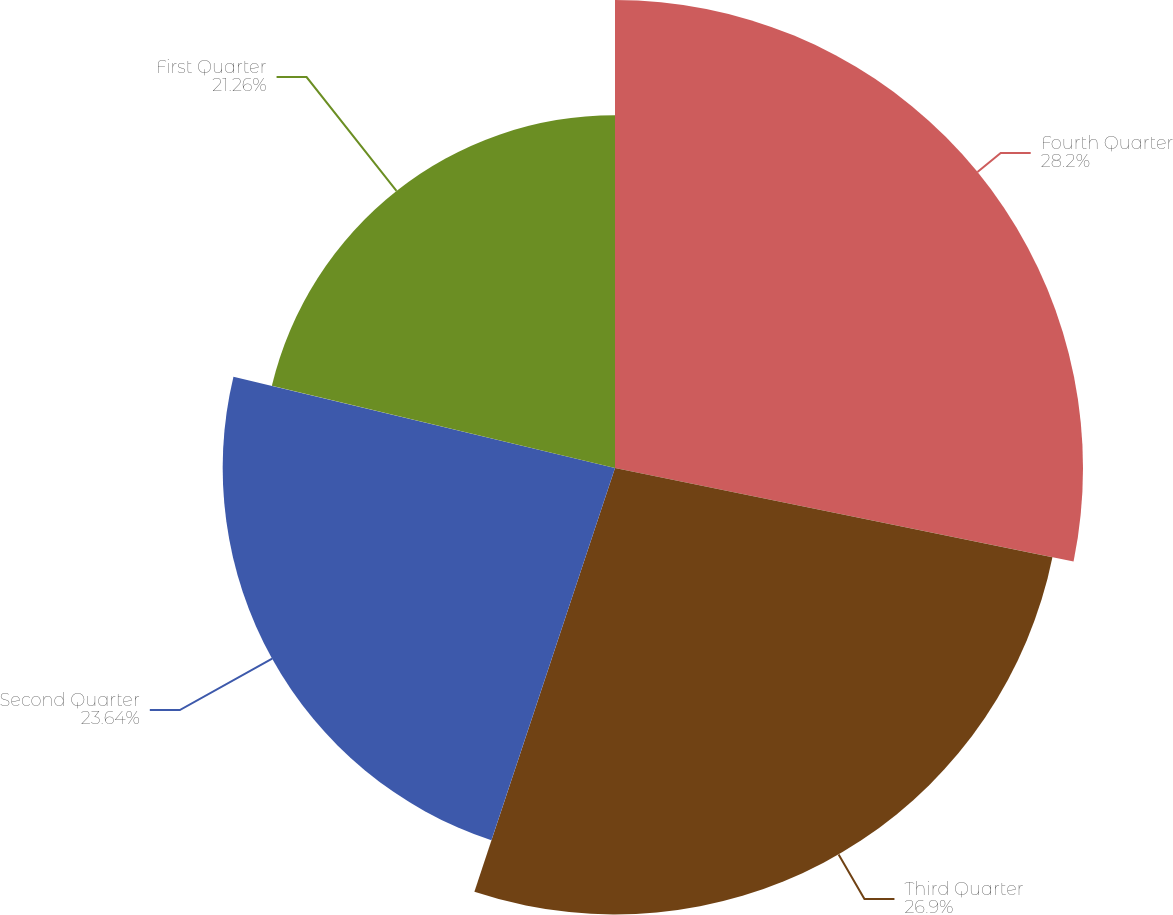<chart> <loc_0><loc_0><loc_500><loc_500><pie_chart><fcel>Fourth Quarter<fcel>Third Quarter<fcel>Second Quarter<fcel>First Quarter<nl><fcel>28.2%<fcel>26.9%<fcel>23.64%<fcel>21.26%<nl></chart> 